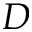<formula> <loc_0><loc_0><loc_500><loc_500>D</formula> 